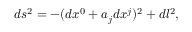Convert formula to latex. <formula><loc_0><loc_0><loc_500><loc_500>d s ^ { 2 } = - ( d x ^ { 0 } + a _ { j } d x ^ { j } ) ^ { 2 } + d l ^ { 2 } ,</formula> 